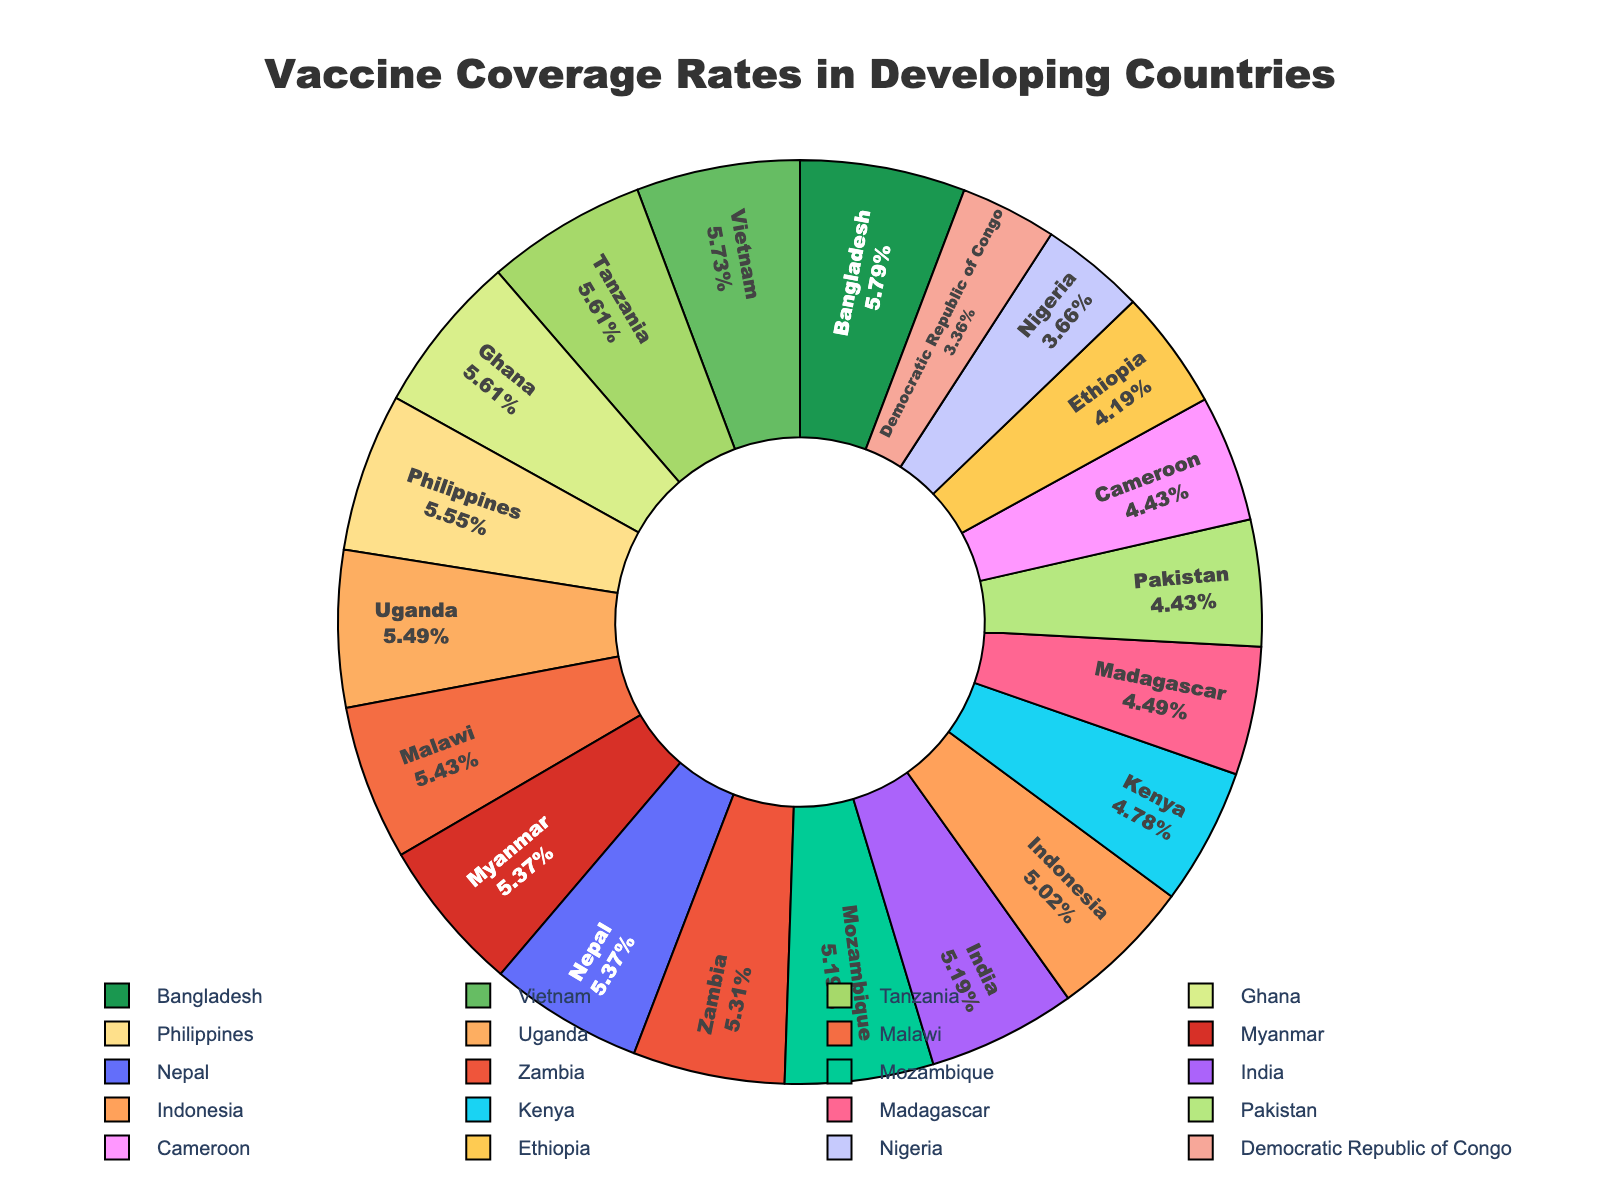What is the country with the lowest vaccine coverage rate? Look at the pie segments and identify the segment corresponding to the lowest value. The Democratic Republic of Congo has the smallest segment with a vaccine coverage rate of 57%.
Answer: Democratic Republic of Congo Which country has the highest vaccine coverage rate? Identify the segment with the largest proportion. Bangladesh has the largest segment with a vaccine coverage rate of 98%.
Answer: Bangladesh How many countries have a vaccine coverage rate of 90% or higher? Count the segments that have a coverage rate of 90% or higher: Bangladesh (98), Tanzania (95), Uganda (93), Philippines (94), Vietnam (97), Ghana (95), Nepal (91), Zambia (90), Malawi (92).
Answer: 9 What is the combined vaccine coverage rate of Kenya, Ethiopia, and Tanzania? Sum the vaccine coverage rates of Kenya (81), Ethiopia (71), and Tanzania (95). 81 + 71 + 95 = 247.
Answer: 247 Which country has a higher vaccine coverage rate, Zambia or Nepal? Compare the coverage rates of Zambia and Nepal. Zambia has 90% and Nepal has 91%.
Answer: Nepal Compare the vaccine coverage rate of Malawi and Madagascar. Look at the pie chart to find the vaccine coverage rates: Malawi is at 92%, while Madagascar is at 76%.
Answer: Malawi What is the difference in vaccine coverage rates between Ghana and Mozambique? Subtract the coverage rate of Mozambique from that of Ghana: 95 - 88 = 7.
Answer: 7 Which country has a vaccine coverage rate closest to 75%? Find the countries with coverage rates around 75%. Both Pakistan and Cameroon have a coverage rate of 75%.
Answer: Pakistan and Cameroon Which color represents Bangladesh, and what is the vaccine coverage rate? Identify the color associated with the segment labeled Bangladesh, it's green, with a coverage rate of 98%.
Answer: Green, 98 Can you identify which countries have a vaccine coverage rate between 80% and 90%? Look at the proportion of each segment in the pie chart: India (88), Indonesia (85), Kenya (81), and Mozambique (88).
Answer: India, Indonesia, Kenya, Mozambique 